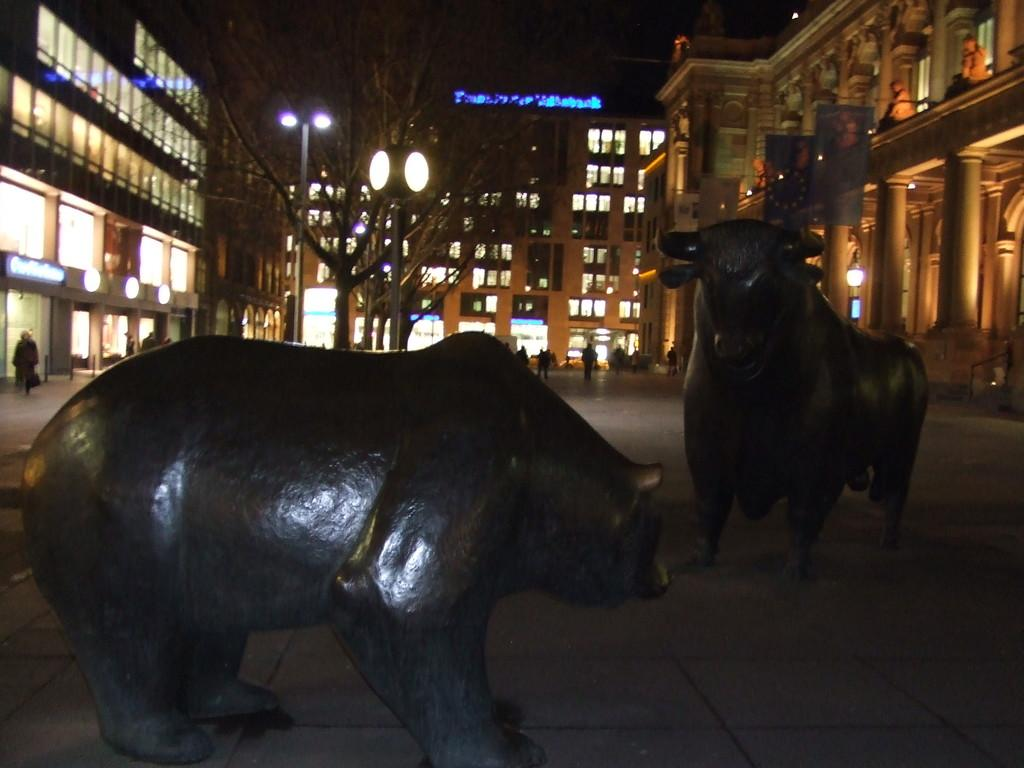How many statues can be seen in the image? There are two statues in the image. What else is happening in the image besides the statues? People are walking on the road in the image. What can be seen in the background of the image? There are buildings, trees, and lights visible in the background of the image. Are there any sheep attacking the statues in the image? No, there are no sheep or attacks present in the image. 